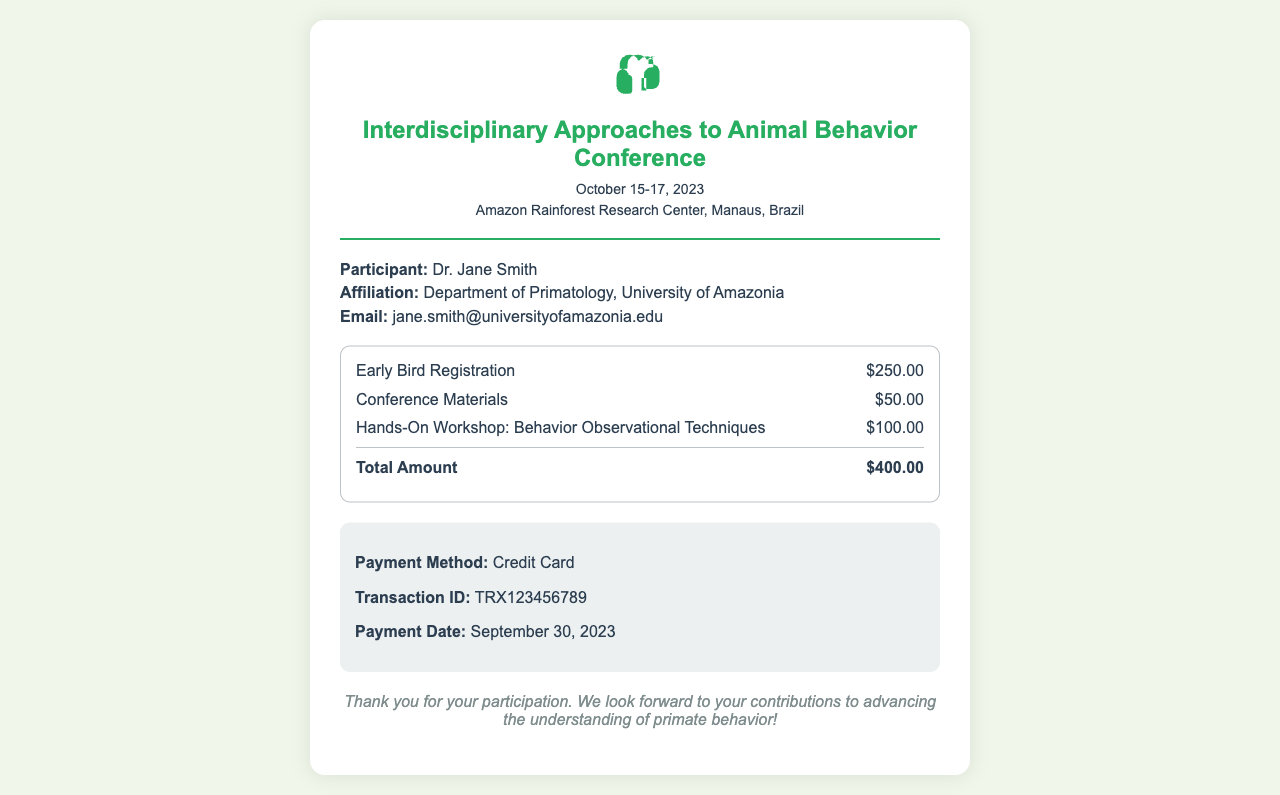What is the name of the conference? The name of the conference is provided in the header section of the document.
Answer: Interdisciplinary Approaches to Animal Behavior Conference What is the total registration fee? The total registration fee is listed in the fee breakdown section of the document.
Answer: $400.00 Who is the participant? The participant's name is mentioned in the participant info section.
Answer: Dr. Jane Smith What is the payment method used? The payment method is specified in the payment info section of the document.
Answer: Credit Card What is the email address of the participant? The email address is provided in the participant info section.
Answer: jane.smith@universityofamazonia.edu When was the payment made? The payment date is stated in the payment info section.
Answer: September 30, 2023 How much does the Hands-On Workshop cost? The cost of the Hands-On Workshop is detailed in the fee breakdown section.
Answer: $100.00 What are the dates of the conference? The dates of the conference are mentioned in the header section.
Answer: October 15-17, 2023 Where is the conference held? The location of the conference is provided in the header section of the document.
Answer: Amazon Rainforest Research Center, Manaus, Brazil 